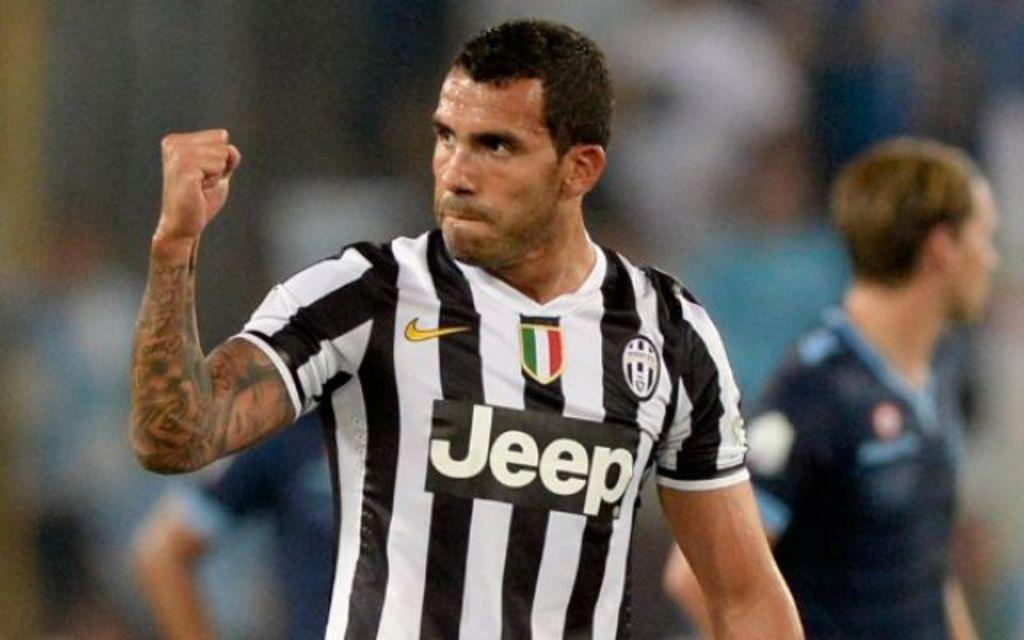Provide a one-sentence caption for the provided image. A soccer referee wearing a Jeep branded shirt, and signaling with his arm. 